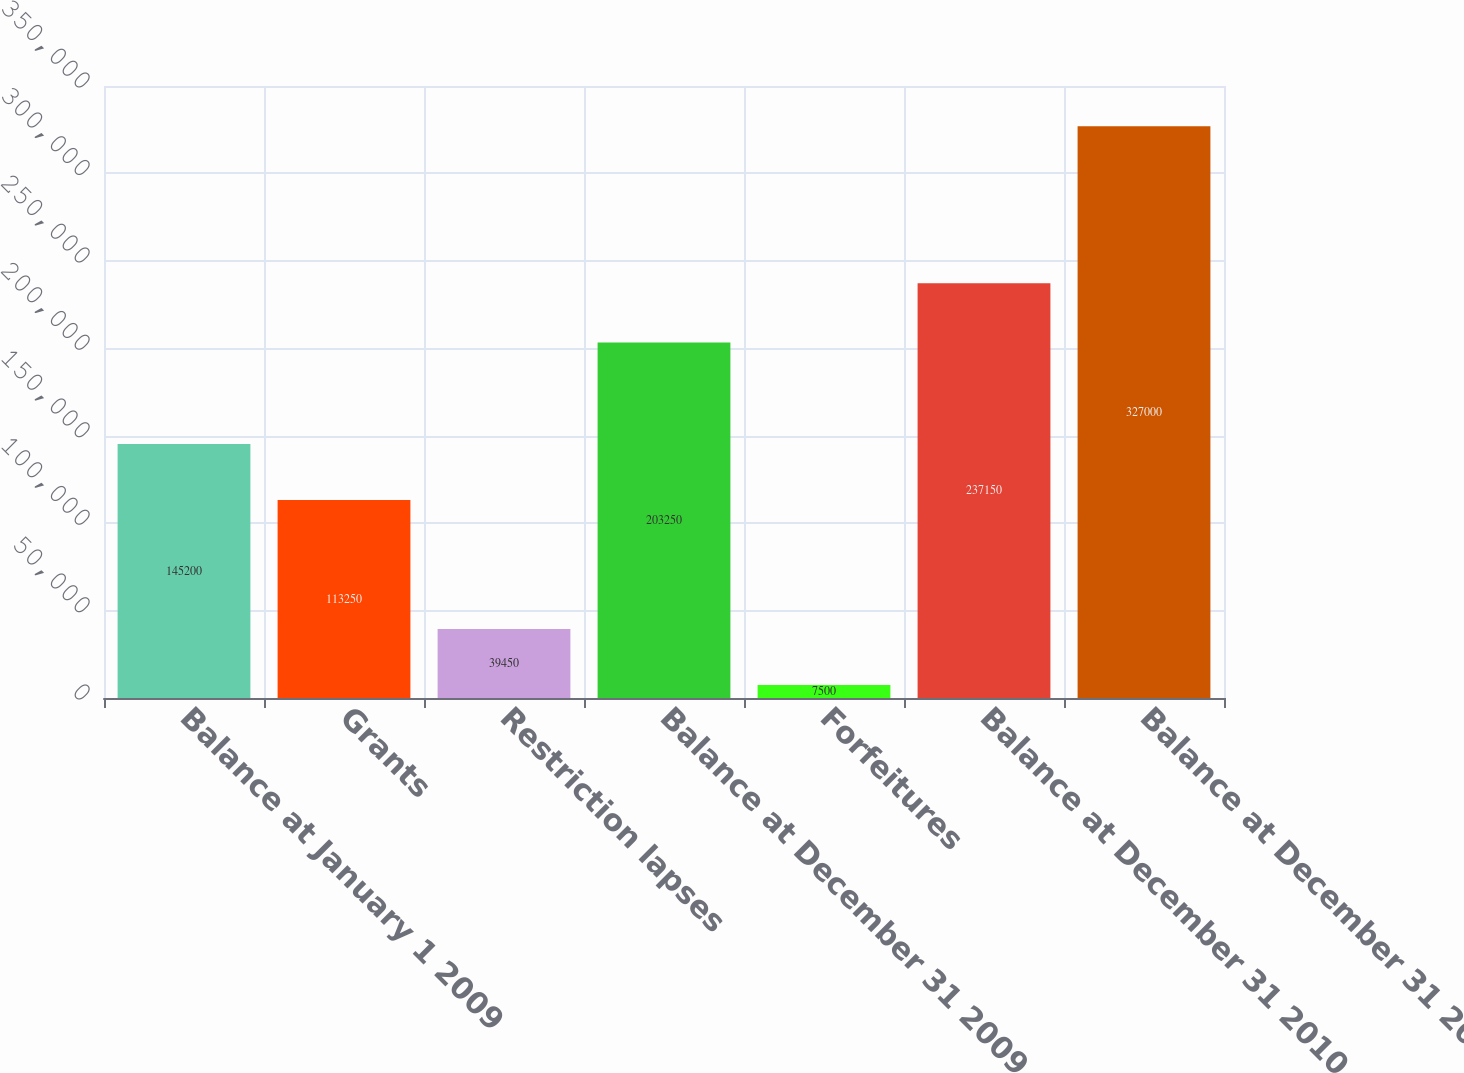Convert chart. <chart><loc_0><loc_0><loc_500><loc_500><bar_chart><fcel>Balance at January 1 2009<fcel>Grants<fcel>Restriction lapses<fcel>Balance at December 31 2009<fcel>Forfeitures<fcel>Balance at December 31 2010<fcel>Balance at December 31 2011<nl><fcel>145200<fcel>113250<fcel>39450<fcel>203250<fcel>7500<fcel>237150<fcel>327000<nl></chart> 